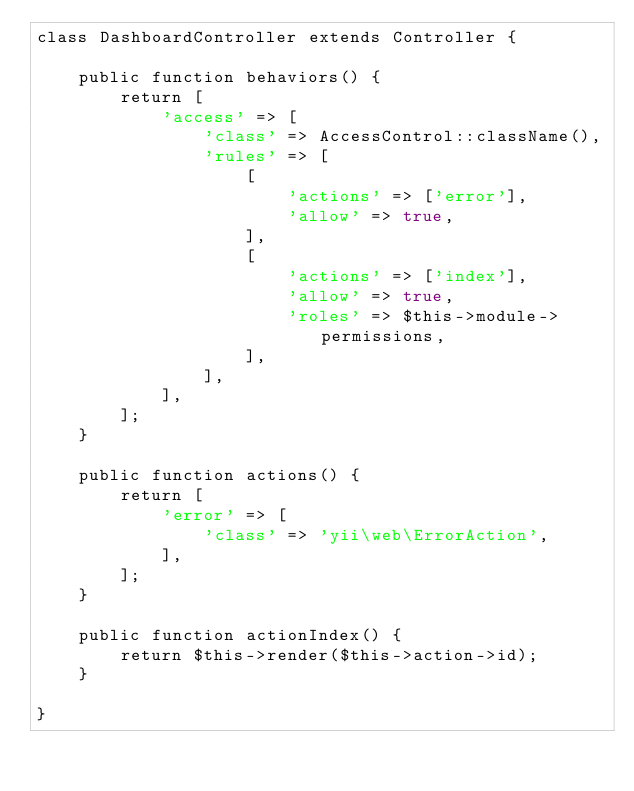Convert code to text. <code><loc_0><loc_0><loc_500><loc_500><_PHP_>class DashboardController extends Controller {

	public function behaviors() {
		return [
			'access' => [
				'class' => AccessControl::className(),
				'rules' => [
					[
						'actions' => ['error'],
						'allow' => true,
					],
					[
						'actions' => ['index'],
						'allow' => true,
						'roles' => $this->module->permissions,
					],
				],
			],
		];
	}

	public function actions() {
		return [
			'error' => [
				'class' => 'yii\web\ErrorAction',
			],
		];
	}

	public function actionIndex() {
		return $this->render($this->action->id);
	}

}
</code> 